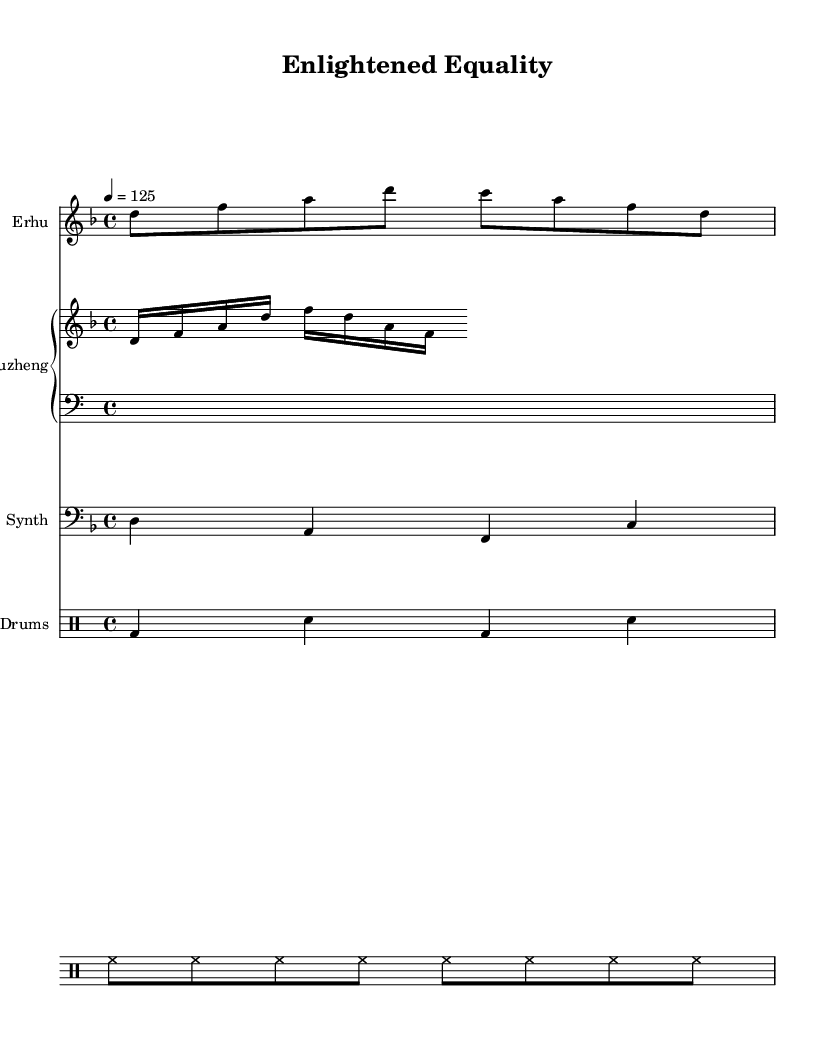What is the key signature of this music? The key signature is indicated by the 'key d minor' statement, which shows that there is one flat (B flat) in the key signature.
Answer: D minor What is the time signature of this music? The time signature is identified through the 'time 4/4' statement, meaning there are four beats in each measure and a quarter note receives one beat.
Answer: 4/4 What is the tempo of this piece? The tempo is noted in the 'tempo 4 = 125' directive, which means the piece should be played at 125 beats per minute.
Answer: 125 Which instrument plays the melody? The melody is played by the 'Erhu', as indicated in the instrument name presented above the staff in the score.
Answer: Erhu How many different instruments are featured in this score? By examining the score, we can see four distinct instruments: Erhu, Guzheng (with two staves for treble and bass), Synth, and Drums.
Answer: Four What rhythmic pattern is used in the drum section? The drum pattern is denoted by the 'bd4 sn bd sn' statement, which represents a bass drum and snare drum pattern over four beats, while the hi-hat is played continuously as shown by the 'hh8' controls.
Answer: Bass drum and snare What is the range of the melody played by the Erhu? The melody is in a relative pitch notation starting at D and extending to A, indicating that the range spans a musical interval of a sixth.
Answer: D to A 